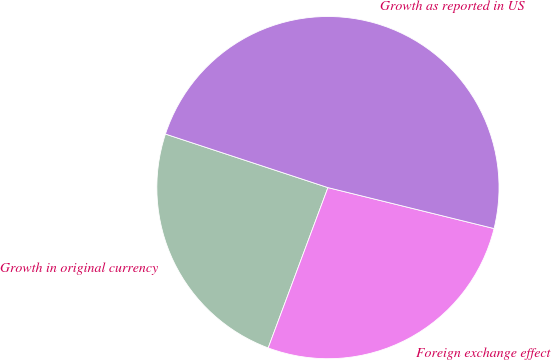Convert chart. <chart><loc_0><loc_0><loc_500><loc_500><pie_chart><fcel>Growth in original currency<fcel>Foreign exchange effect<fcel>Growth as reported in US<nl><fcel>24.39%<fcel>26.83%<fcel>48.78%<nl></chart> 